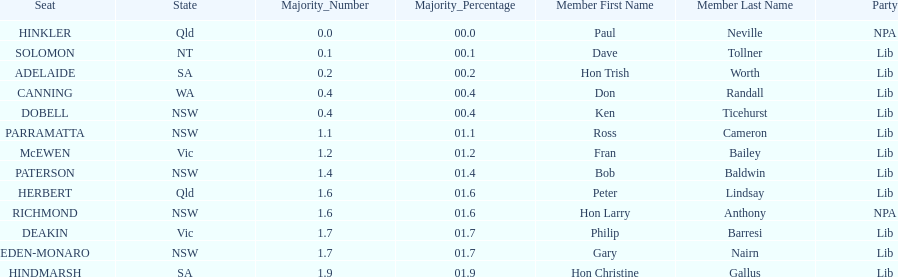What is the total of seats? 13. 